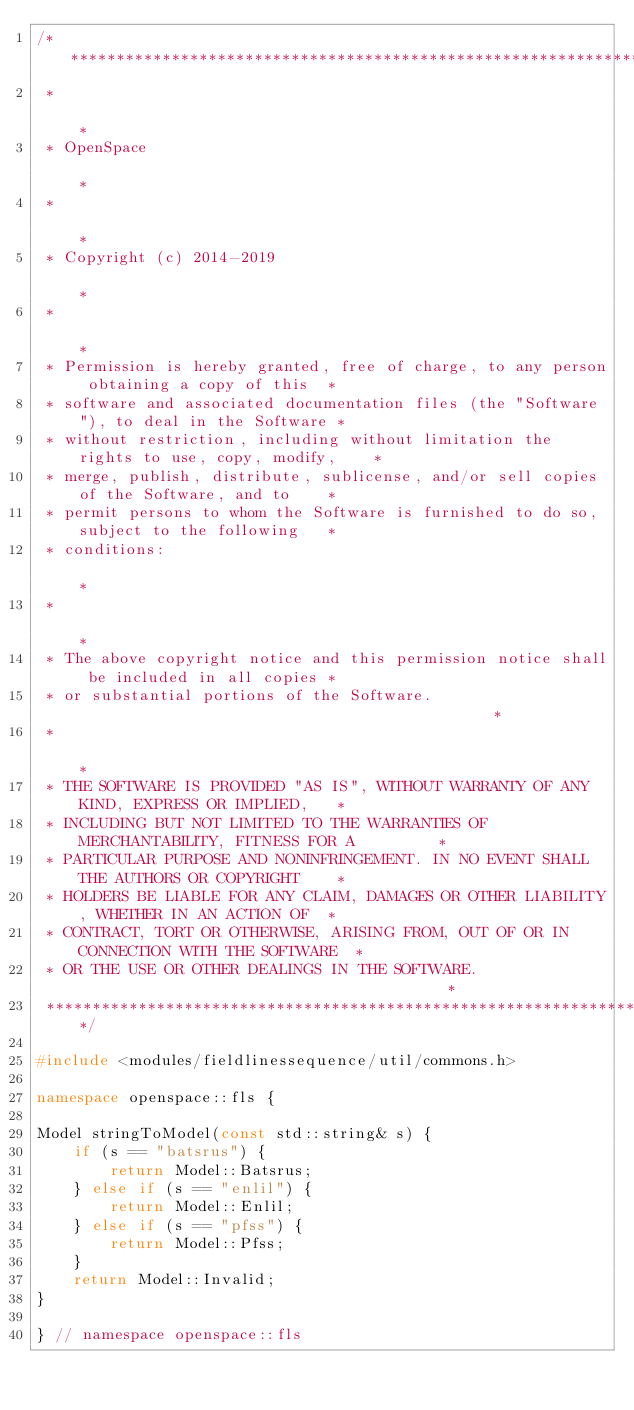Convert code to text. <code><loc_0><loc_0><loc_500><loc_500><_C++_>/*****************************************************************************************
 *                                                                                       *
 * OpenSpace                                                                             *
 *                                                                                       *
 * Copyright (c) 2014-2019                                                               *
 *                                                                                       *
 * Permission is hereby granted, free of charge, to any person obtaining a copy of this  *
 * software and associated documentation files (the "Software"), to deal in the Software *
 * without restriction, including without limitation the rights to use, copy, modify,    *
 * merge, publish, distribute, sublicense, and/or sell copies of the Software, and to    *
 * permit persons to whom the Software is furnished to do so, subject to the following   *
 * conditions:                                                                           *
 *                                                                                       *
 * The above copyright notice and this permission notice shall be included in all copies *
 * or substantial portions of the Software.                                              *
 *                                                                                       *
 * THE SOFTWARE IS PROVIDED "AS IS", WITHOUT WARRANTY OF ANY KIND, EXPRESS OR IMPLIED,   *
 * INCLUDING BUT NOT LIMITED TO THE WARRANTIES OF MERCHANTABILITY, FITNESS FOR A         *
 * PARTICULAR PURPOSE AND NONINFRINGEMENT. IN NO EVENT SHALL THE AUTHORS OR COPYRIGHT    *
 * HOLDERS BE LIABLE FOR ANY CLAIM, DAMAGES OR OTHER LIABILITY, WHETHER IN AN ACTION OF  *
 * CONTRACT, TORT OR OTHERWISE, ARISING FROM, OUT OF OR IN CONNECTION WITH THE SOFTWARE  *
 * OR THE USE OR OTHER DEALINGS IN THE SOFTWARE.                                         *
 ****************************************************************************************/

#include <modules/fieldlinessequence/util/commons.h>

namespace openspace::fls {

Model stringToModel(const std::string& s) {
    if (s == "batsrus") {
        return Model::Batsrus;
    } else if (s == "enlil") {
        return Model::Enlil;
    } else if (s == "pfss") {
        return Model::Pfss;
    }
    return Model::Invalid;
}

} // namespace openspace::fls
</code> 